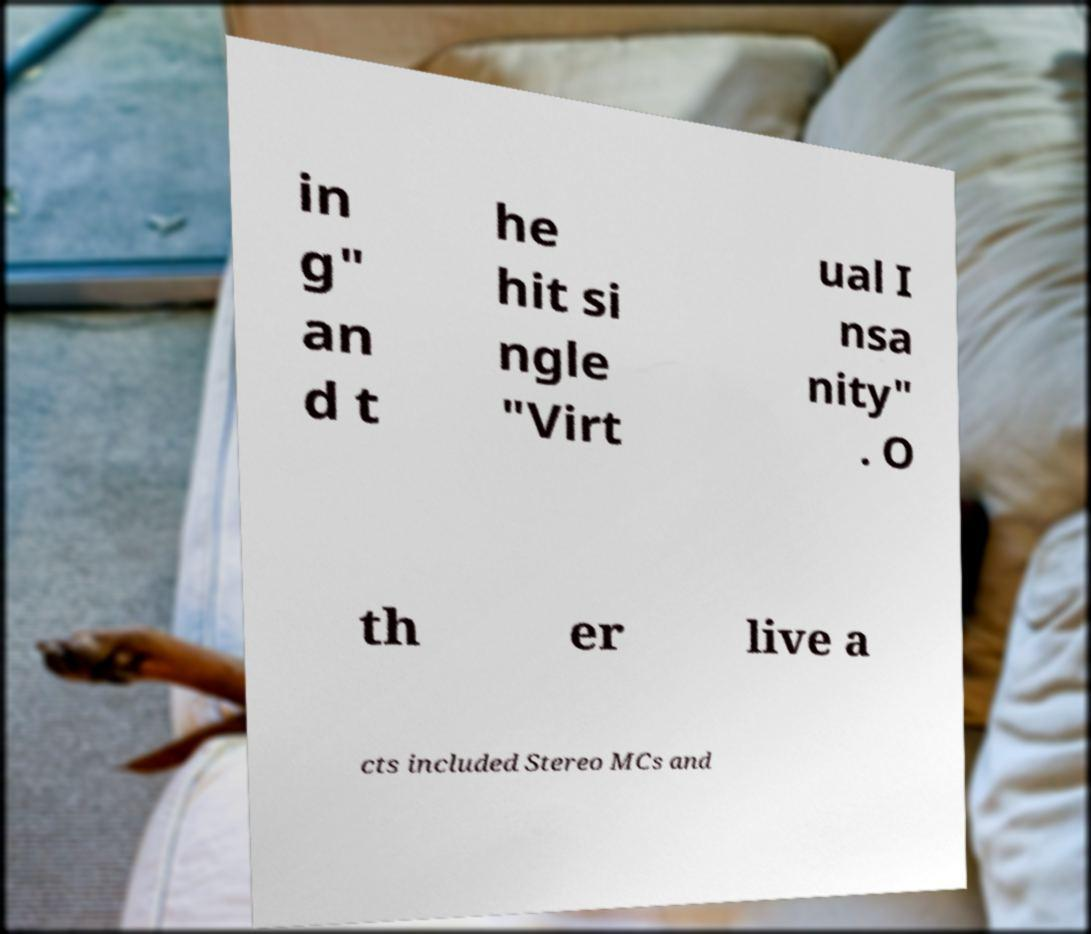Can you accurately transcribe the text from the provided image for me? in g" an d t he hit si ngle "Virt ual I nsa nity" . O th er live a cts included Stereo MCs and 